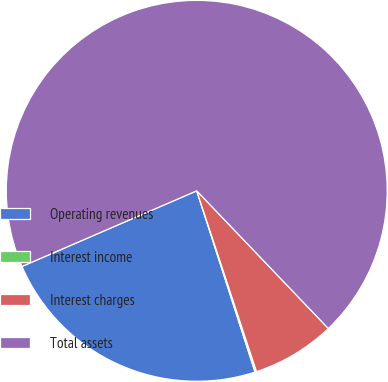Convert chart to OTSL. <chart><loc_0><loc_0><loc_500><loc_500><pie_chart><fcel>Operating revenues<fcel>Interest income<fcel>Interest charges<fcel>Total assets<nl><fcel>23.45%<fcel>0.13%<fcel>7.06%<fcel>69.36%<nl></chart> 